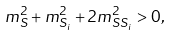Convert formula to latex. <formula><loc_0><loc_0><loc_500><loc_500>m _ { S } ^ { 2 } + m _ { S _ { i } } ^ { 2 } + 2 m _ { S S _ { i } } ^ { 2 } > 0 ,</formula> 